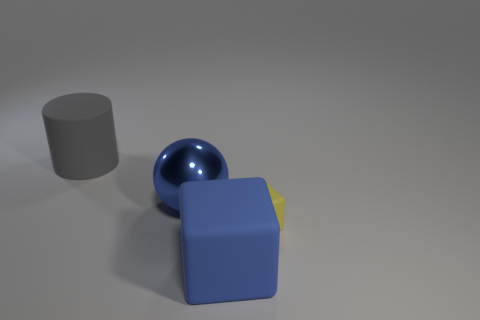Add 2 small red metal balls. How many objects exist? 6 Subtract all balls. How many objects are left? 3 Subtract 1 spheres. How many spheres are left? 0 Add 4 gray rubber cylinders. How many gray rubber cylinders are left? 5 Add 4 tiny rubber things. How many tiny rubber things exist? 5 Subtract 1 gray cylinders. How many objects are left? 3 Subtract all green cylinders. Subtract all brown cubes. How many cylinders are left? 1 Subtract all green cubes. How many brown spheres are left? 0 Subtract all small rubber blocks. Subtract all brown cylinders. How many objects are left? 3 